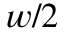<formula> <loc_0><loc_0><loc_500><loc_500>w / 2</formula> 